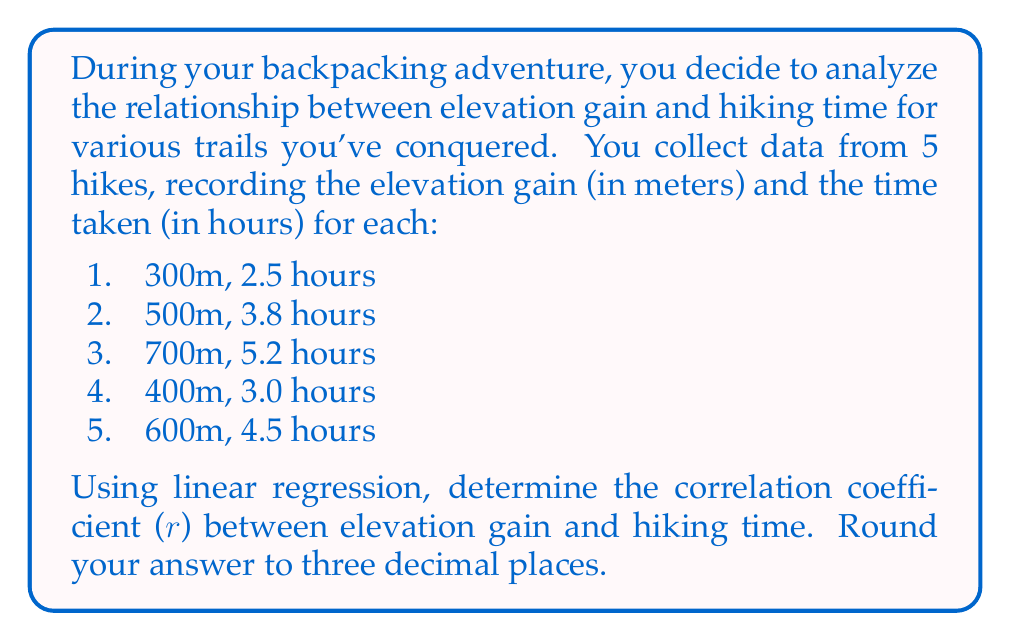Help me with this question. To solve this problem, we'll use the formula for the correlation coefficient in linear regression:

$$r = \frac{n\sum xy - \sum x \sum y}{\sqrt{[n\sum x^2 - (\sum x)^2][n\sum y^2 - (\sum y)^2]}}$$

Where:
$n$ = number of data points
$x$ = elevation gain
$y$ = hiking time

Let's calculate the required sums:

1. $n = 5$
2. $\sum x = 300 + 500 + 700 + 400 + 600 = 2500$
3. $\sum y = 2.5 + 3.8 + 5.2 + 3.0 + 4.5 = 19$
4. $\sum xy = (300)(2.5) + (500)(3.8) + (700)(5.2) + (400)(3.0) + (600)(4.5) = 10060$
5. $\sum x^2 = 300^2 + 500^2 + 700^2 + 400^2 + 600^2 = 1,390,000$
6. $\sum y^2 = 2.5^2 + 3.8^2 + 5.2^2 + 3.0^2 + 4.5^2 = 76.78$

Now, let's substitute these values into the correlation coefficient formula:

$$r = \frac{5(10060) - (2500)(19)}{\sqrt{[5(1390000) - (2500)^2][5(76.78) - (19)^2]}}$$

$$r = \frac{50300 - 47500}{\sqrt{(6950000 - 6250000)(383.9 - 361)}}$$

$$r = \frac{2800}{\sqrt{(700000)(22.9)}}$$

$$r = \frac{2800}{\sqrt{16030000}}$$

$$r = \frac{2800}{4004.997}$$

$$r \approx 0.699$$

Rounding to three decimal places, we get 0.699.
Answer: 0.699 